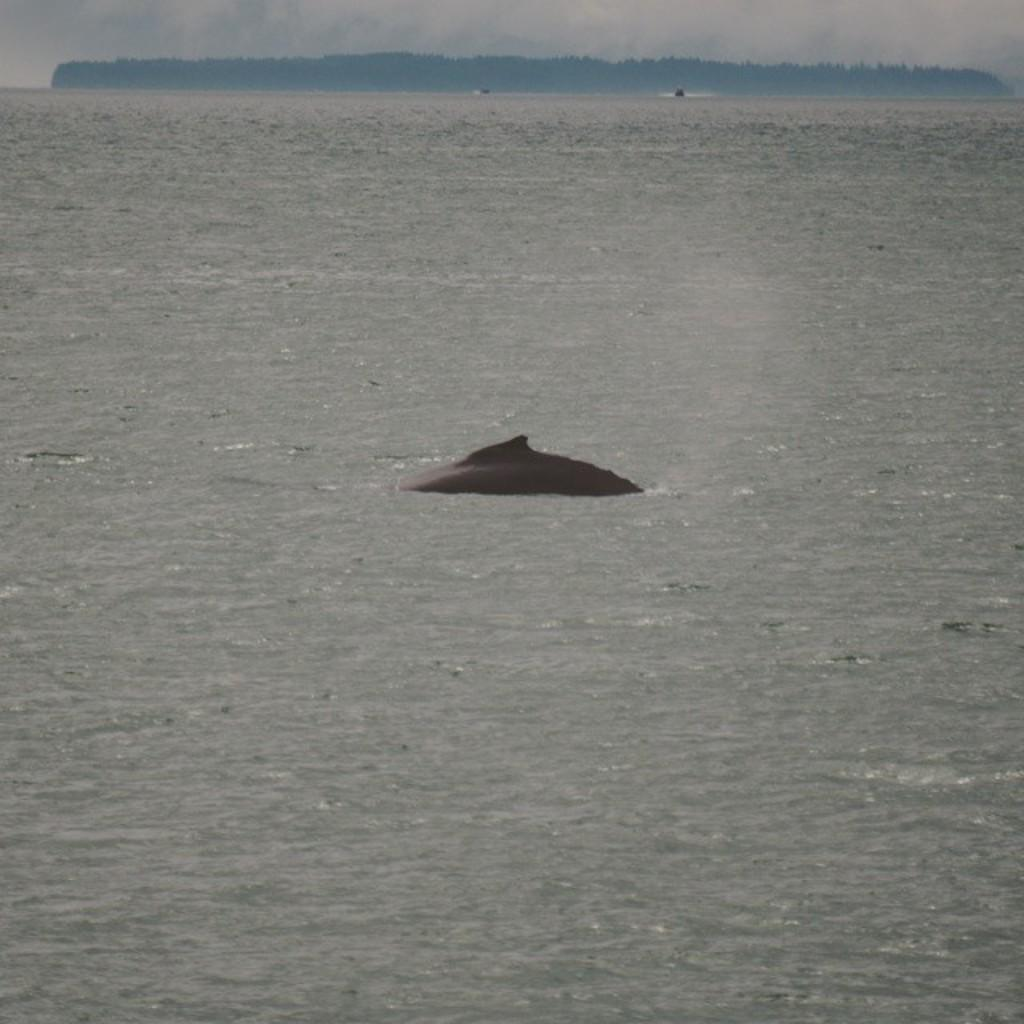What is the main subject in the center of the image? There is a whale or a dolphin in the center of the image. What is the environment surrounding the whale or dolphin? The whale or dolphin is in a sea. What type of vegetation can be seen towards the top of the image? There are trees visible towards the top of the image. What is visible at the top of the image? The sky is visible at the top of the image. What route does the whale or dolphin take to participate in the battle in the image? There is no battle present in the image, and therefore no route for the whale or dolphin to participate in one. 